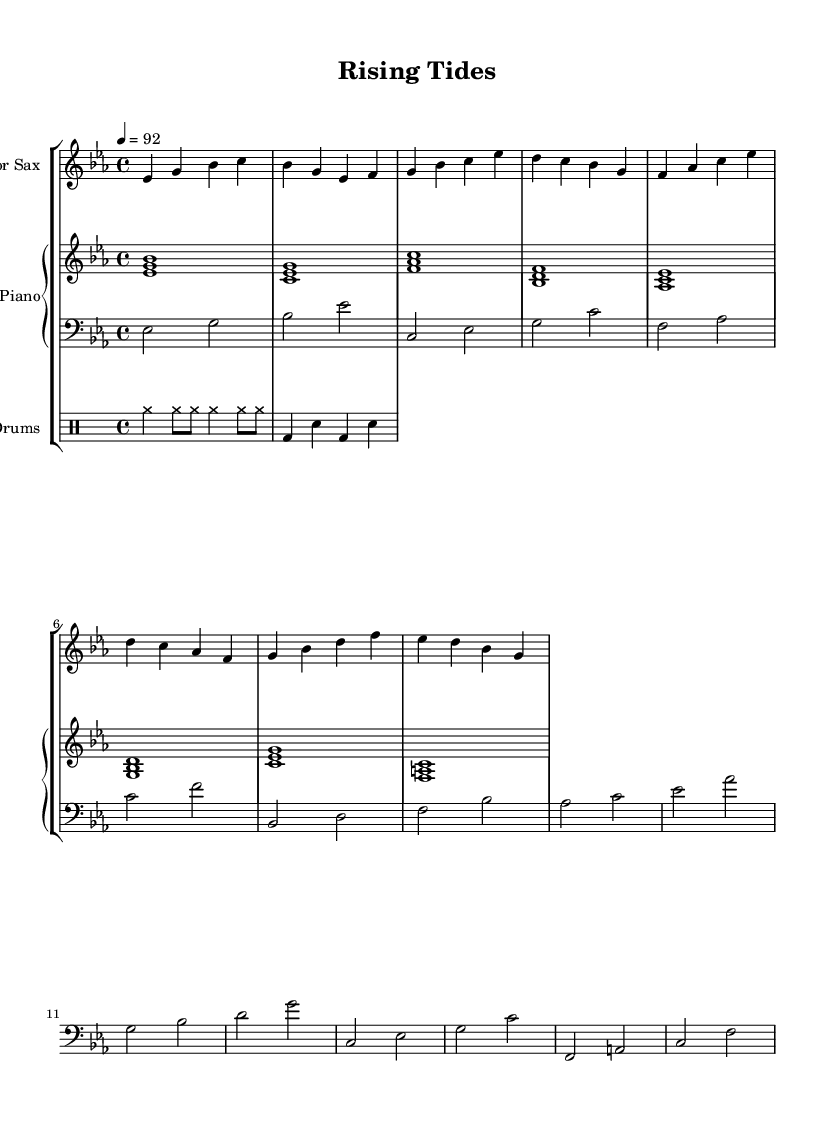what is the key signature of this music? The key signature is indicated by the presence of three flats (B♭, E♭, A♭) in the notation. This corresponds to E♭ major, which has three flats.
Answer: E♭ major what is the time signature of this music? The time signature is represented as a fraction at the beginning of the sheet music. It shows 4 beats in each measure, indicating a 4/4 time signature.
Answer: 4/4 what is the tempo marking of this music? The tempo marking indicates the speed of the piece and is given as a number following the "tempo" text. In this case, it shows 92 beats per minute.
Answer: 92 how many measures are there in the saxophone part? By counting the groupings of notes separated by vertical barlines, we can determine there are 8 measures in the saxophone part.
Answer: 8 which instrument plays the bass part? The clef at the beginning of the bass part indicates it is written for bass instruments, specifically the bass guitar or upright bass.
Answer: Bass what is the primary theme of this piece based on the title? The title "Rising Tides" suggests a thematic exploration related to climate resilience or adaptation, possibly symbolizing the struggles against rising sea levels.
Answer: Climate resilience how are the drum rhythms structured in this music? The rhythmic patterns for the drums are indicated in a specialized notation called drummode. The pattern alternates between cymbal and bass drum hits, establishing a steady rhythmic foundation.
Answer: Alternating cymbals and bass drum beats 